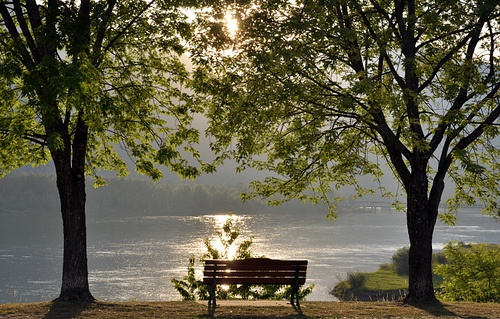Describe the objects in this image and their specific colors. I can see a bench in darkgreen, black, olive, maroon, and gray tones in this image. 